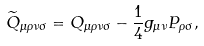<formula> <loc_0><loc_0><loc_500><loc_500>\widetilde { Q } _ { \mu \rho \nu \sigma } = { Q } _ { \mu \rho \nu \sigma } - \frac { 1 } { 4 } g _ { \mu \nu } P _ { \rho \sigma } ,</formula> 